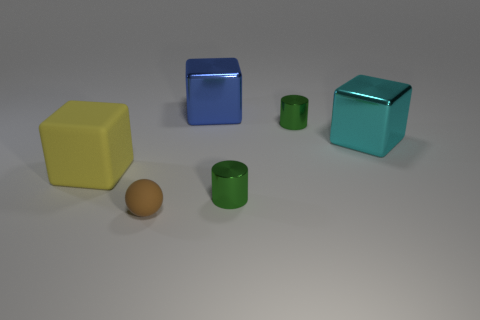Add 1 balls. How many objects exist? 7 Subtract all balls. How many objects are left? 5 Subtract 0 purple balls. How many objects are left? 6 Subtract all tiny brown matte things. Subtract all cylinders. How many objects are left? 3 Add 6 brown spheres. How many brown spheres are left? 7 Add 5 large yellow matte spheres. How many large yellow matte spheres exist? 5 